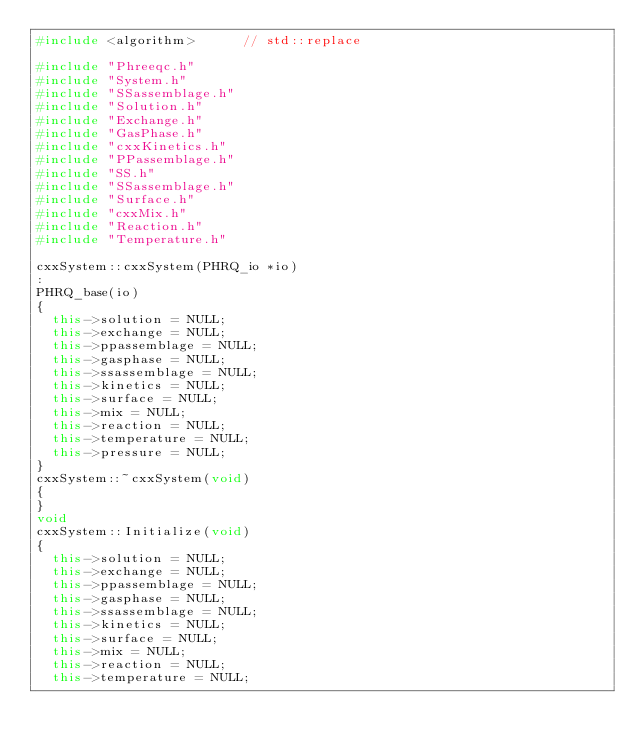<code> <loc_0><loc_0><loc_500><loc_500><_C++_>#include <algorithm>			// std::replace 

#include "Phreeqc.h"
#include "System.h"
#include "SSassemblage.h"
#include "Solution.h"
#include "Exchange.h"
#include "GasPhase.h"
#include "cxxKinetics.h"
#include "PPassemblage.h"
#include "SS.h"
#include "SSassemblage.h"
#include "Surface.h"
#include "cxxMix.h"
#include "Reaction.h"
#include "Temperature.h"

cxxSystem::cxxSystem(PHRQ_io *io)
:
PHRQ_base(io)
{
	this->solution = NULL;
	this->exchange = NULL;
	this->ppassemblage = NULL;
	this->gasphase = NULL;
	this->ssassemblage = NULL;
	this->kinetics = NULL;
	this->surface = NULL;
	this->mix = NULL;
	this->reaction = NULL;
	this->temperature = NULL;
	this->pressure = NULL;
} 
cxxSystem::~cxxSystem(void) 
{
} 
void
cxxSystem::Initialize(void) 
{
	this->solution = NULL;
	this->exchange = NULL;
	this->ppassemblage = NULL;
	this->gasphase = NULL;
	this->ssassemblage = NULL;
	this->kinetics = NULL;
	this->surface = NULL;
	this->mix = NULL;
	this->reaction = NULL;
	this->temperature = NULL;</code> 